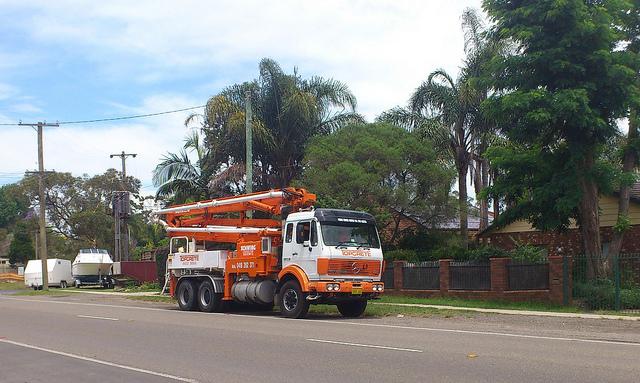What is the fence in front of the truck made of?
Give a very brief answer. Brick and iron. What kind of vehicle is this?
Be succinct. Truck. Is the street busy?
Write a very short answer. No. Are the trucks new?
Short answer required. Yes. What color is the fence?
Keep it brief. Black. 